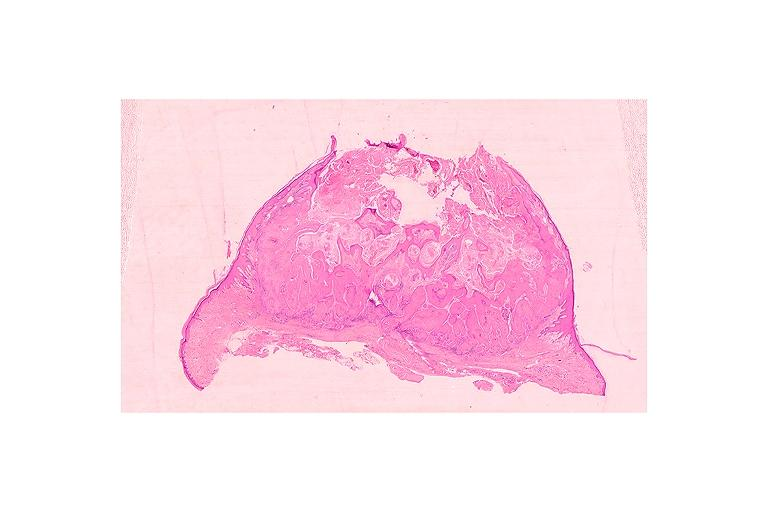does this image show keratoacanthoma?
Answer the question using a single word or phrase. Yes 